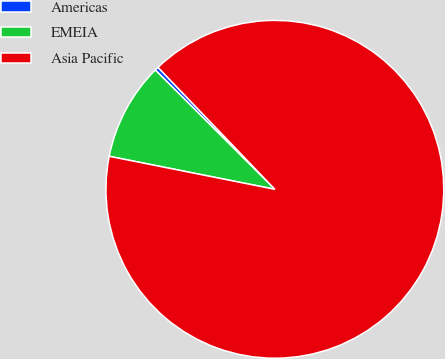Convert chart to OTSL. <chart><loc_0><loc_0><loc_500><loc_500><pie_chart><fcel>Americas<fcel>EMEIA<fcel>Asia Pacific<nl><fcel>0.36%<fcel>9.35%<fcel>90.29%<nl></chart> 